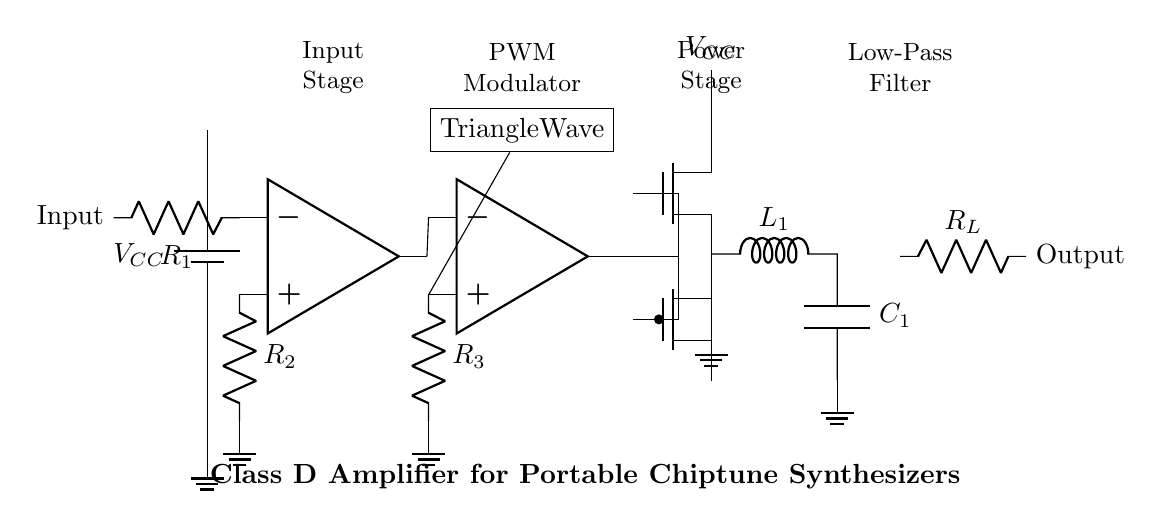What is the power supply voltage denoted in the circuit? The circuit diagram shows the battery labeled as VCC, which denotes the power supply voltage.
Answer: VCC What is the purpose of R1 in the input stage? R1 is connected to the inverting input of the operational amplifier, which helps set the gain and stability of the amplifier by controlling feedback.
Answer: Gain stability What type of amplifier is depicted in this circuit? The circuit is clearly labeled as a Class D amplifier, which is known for its high efficiency in converting digital signals to amplified outputs.
Answer: Class D What is the role of the triangle wave generator in this circuit? The triangle wave generator provides a reference signal to the comparator, which is essential for pulse width modulation (PWM) that drives the power stage.
Answer: PWM signal generation How many operational amplifiers are used in this circuit? Upon examining the diagram, there are two operational amplifiers indicated: one for the input stage and another for the comparator stage.
Answer: Two What is the function of the low-pass filter in this circuit? The low-pass filter, comprised of an inductor and capacitor, smooths out the PWM signal to produce a clean analog output signal to drive the load.
Answer: Signal smoothing 